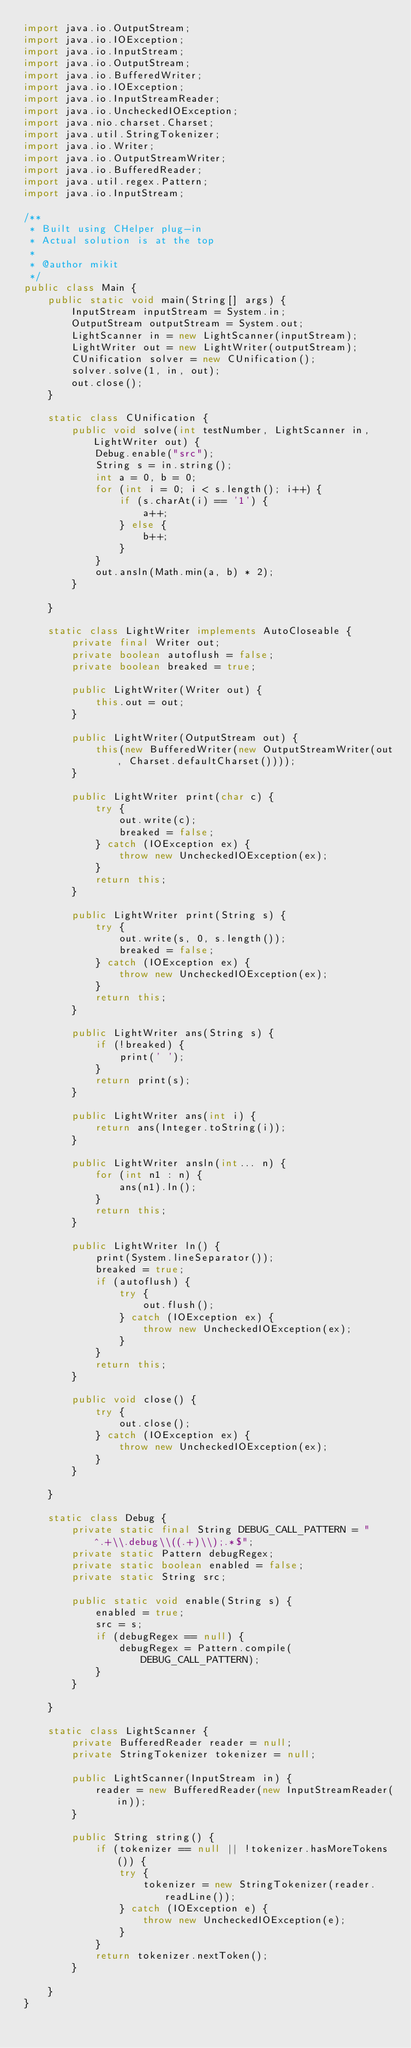<code> <loc_0><loc_0><loc_500><loc_500><_Java_>import java.io.OutputStream;
import java.io.IOException;
import java.io.InputStream;
import java.io.OutputStream;
import java.io.BufferedWriter;
import java.io.IOException;
import java.io.InputStreamReader;
import java.io.UncheckedIOException;
import java.nio.charset.Charset;
import java.util.StringTokenizer;
import java.io.Writer;
import java.io.OutputStreamWriter;
import java.io.BufferedReader;
import java.util.regex.Pattern;
import java.io.InputStream;

/**
 * Built using CHelper plug-in
 * Actual solution is at the top
 *
 * @author mikit
 */
public class Main {
    public static void main(String[] args) {
        InputStream inputStream = System.in;
        OutputStream outputStream = System.out;
        LightScanner in = new LightScanner(inputStream);
        LightWriter out = new LightWriter(outputStream);
        CUnification solver = new CUnification();
        solver.solve(1, in, out);
        out.close();
    }

    static class CUnification {
        public void solve(int testNumber, LightScanner in, LightWriter out) {
            Debug.enable("src");
            String s = in.string();
            int a = 0, b = 0;
            for (int i = 0; i < s.length(); i++) {
                if (s.charAt(i) == '1') {
                    a++;
                } else {
                    b++;
                }
            }
            out.ansln(Math.min(a, b) * 2);
        }

    }

    static class LightWriter implements AutoCloseable {
        private final Writer out;
        private boolean autoflush = false;
        private boolean breaked = true;

        public LightWriter(Writer out) {
            this.out = out;
        }

        public LightWriter(OutputStream out) {
            this(new BufferedWriter(new OutputStreamWriter(out, Charset.defaultCharset())));
        }

        public LightWriter print(char c) {
            try {
                out.write(c);
                breaked = false;
            } catch (IOException ex) {
                throw new UncheckedIOException(ex);
            }
            return this;
        }

        public LightWriter print(String s) {
            try {
                out.write(s, 0, s.length());
                breaked = false;
            } catch (IOException ex) {
                throw new UncheckedIOException(ex);
            }
            return this;
        }

        public LightWriter ans(String s) {
            if (!breaked) {
                print(' ');
            }
            return print(s);
        }

        public LightWriter ans(int i) {
            return ans(Integer.toString(i));
        }

        public LightWriter ansln(int... n) {
            for (int n1 : n) {
                ans(n1).ln();
            }
            return this;
        }

        public LightWriter ln() {
            print(System.lineSeparator());
            breaked = true;
            if (autoflush) {
                try {
                    out.flush();
                } catch (IOException ex) {
                    throw new UncheckedIOException(ex);
                }
            }
            return this;
        }

        public void close() {
            try {
                out.close();
            } catch (IOException ex) {
                throw new UncheckedIOException(ex);
            }
        }

    }

    static class Debug {
        private static final String DEBUG_CALL_PATTERN = "^.+\\.debug\\((.+)\\);.*$";
        private static Pattern debugRegex;
        private static boolean enabled = false;
        private static String src;

        public static void enable(String s) {
            enabled = true;
            src = s;
            if (debugRegex == null) {
                debugRegex = Pattern.compile(DEBUG_CALL_PATTERN);
            }
        }

    }

    static class LightScanner {
        private BufferedReader reader = null;
        private StringTokenizer tokenizer = null;

        public LightScanner(InputStream in) {
            reader = new BufferedReader(new InputStreamReader(in));
        }

        public String string() {
            if (tokenizer == null || !tokenizer.hasMoreTokens()) {
                try {
                    tokenizer = new StringTokenizer(reader.readLine());
                } catch (IOException e) {
                    throw new UncheckedIOException(e);
                }
            }
            return tokenizer.nextToken();
        }

    }
}

</code> 